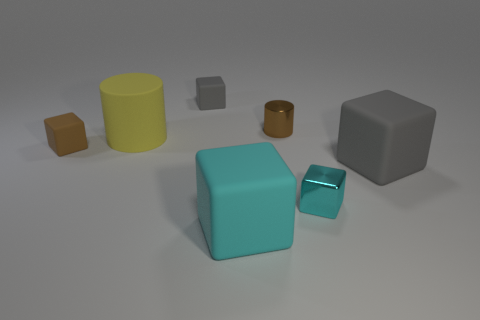There is a shiny cube that is the same size as the brown rubber thing; what color is it?
Provide a short and direct response. Cyan. Is the tiny brown object that is right of the large yellow thing made of the same material as the tiny gray object?
Keep it short and to the point. No. What size is the rubber block that is the same color as the tiny metal cylinder?
Your response must be concise. Small. How many other cyan matte blocks have the same size as the cyan rubber cube?
Offer a terse response. 0. Is the number of metallic objects that are in front of the big gray cube the same as the number of gray blocks?
Your answer should be compact. No. What number of objects are in front of the small cylinder and right of the big cyan cube?
Give a very brief answer. 2. What size is the yellow object that is made of the same material as the big cyan object?
Your answer should be very brief. Large. What number of gray matte objects have the same shape as the cyan shiny thing?
Keep it short and to the point. 2. Are there more large cylinders that are right of the small gray rubber block than big brown metallic cylinders?
Offer a very short reply. No. The large object that is behind the large cyan cube and in front of the brown matte cube has what shape?
Your response must be concise. Cube. 